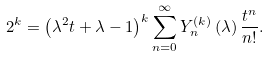<formula> <loc_0><loc_0><loc_500><loc_500>2 ^ { k } = \left ( \lambda ^ { 2 } t + \lambda - 1 \right ) ^ { k } \sum _ { n = 0 } ^ { \infty } Y _ { n } ^ { \left ( k \right ) } \left ( \lambda \right ) \frac { t ^ { n } } { n ! } .</formula> 